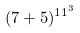<formula> <loc_0><loc_0><loc_500><loc_500>( 7 + 5 ) ^ { 1 1 ^ { 3 } }</formula> 